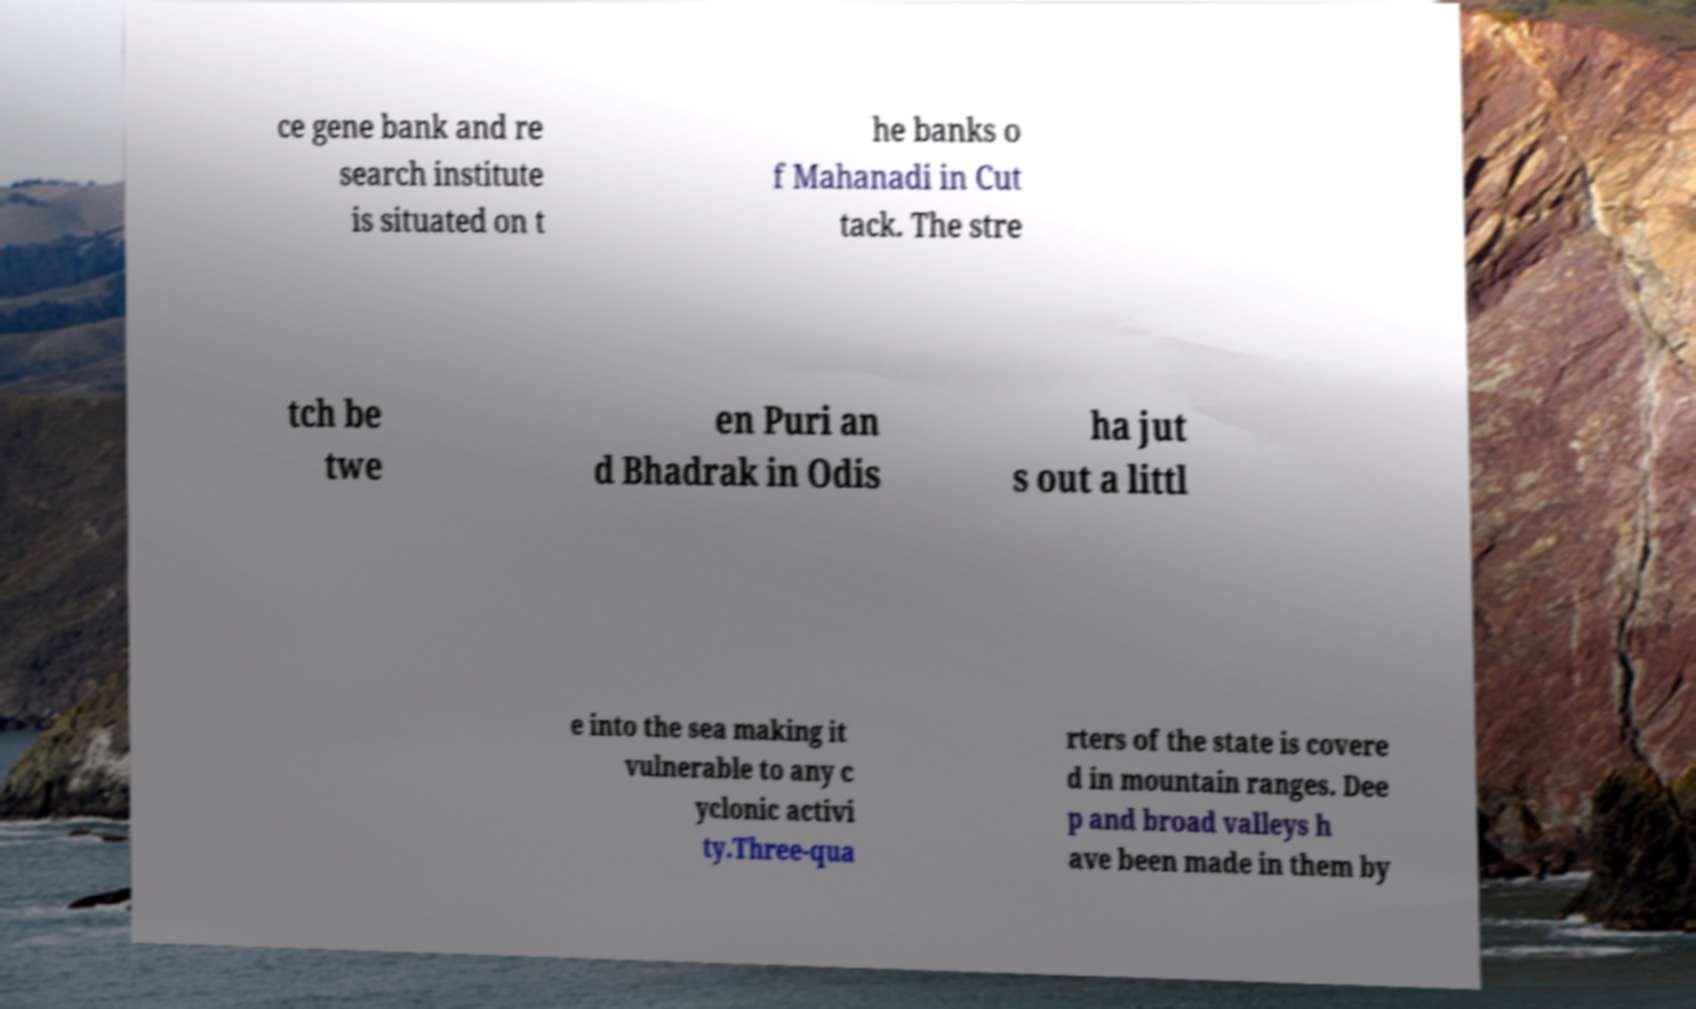Can you accurately transcribe the text from the provided image for me? ce gene bank and re search institute is situated on t he banks o f Mahanadi in Cut tack. The stre tch be twe en Puri an d Bhadrak in Odis ha jut s out a littl e into the sea making it vulnerable to any c yclonic activi ty.Three-qua rters of the state is covere d in mountain ranges. Dee p and broad valleys h ave been made in them by 